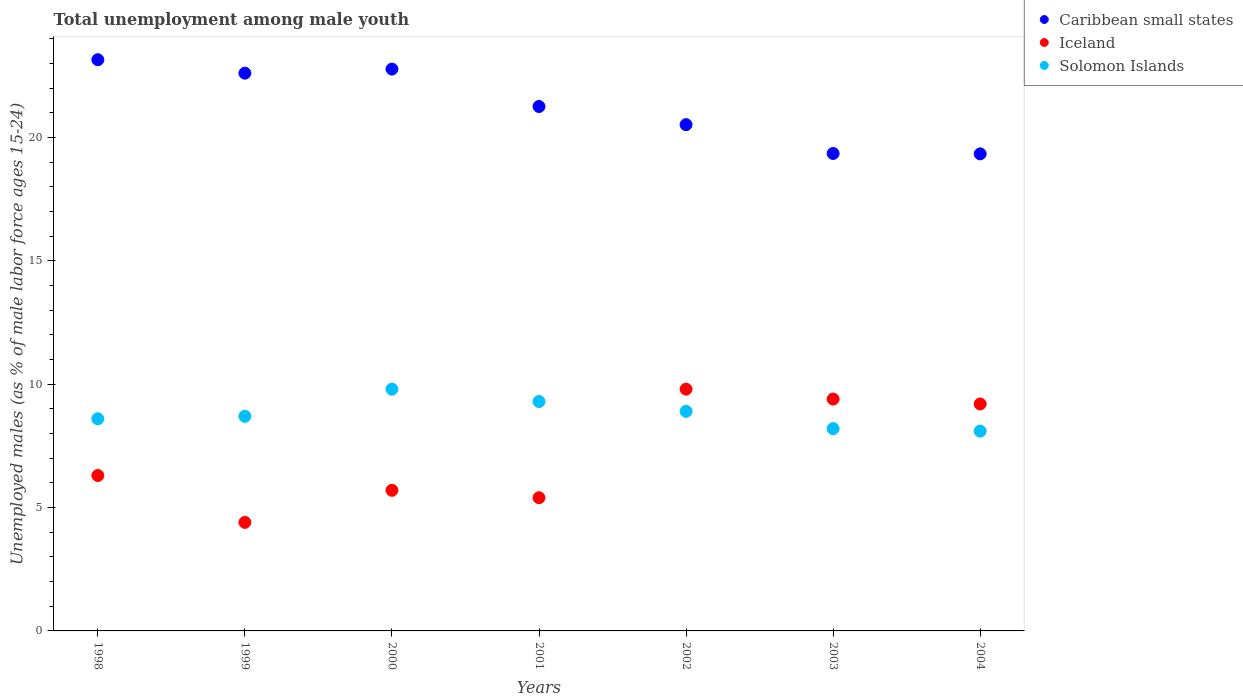Is the number of dotlines equal to the number of legend labels?
Make the answer very short. Yes. What is the percentage of unemployed males in in Caribbean small states in 1999?
Your response must be concise. 22.61. Across all years, what is the maximum percentage of unemployed males in in Solomon Islands?
Your answer should be compact. 9.8. Across all years, what is the minimum percentage of unemployed males in in Caribbean small states?
Provide a succinct answer. 19.34. What is the total percentage of unemployed males in in Iceland in the graph?
Your answer should be very brief. 50.2. What is the difference between the percentage of unemployed males in in Caribbean small states in 1998 and that in 2002?
Your answer should be compact. 2.63. What is the difference between the percentage of unemployed males in in Solomon Islands in 2004 and the percentage of unemployed males in in Iceland in 1999?
Offer a terse response. 3.7. What is the average percentage of unemployed males in in Iceland per year?
Offer a terse response. 7.17. In the year 2002, what is the difference between the percentage of unemployed males in in Caribbean small states and percentage of unemployed males in in Iceland?
Keep it short and to the point. 10.72. What is the ratio of the percentage of unemployed males in in Caribbean small states in 1998 to that in 2004?
Offer a terse response. 1.2. Is the percentage of unemployed males in in Solomon Islands in 1998 less than that in 2000?
Give a very brief answer. Yes. What is the difference between the highest and the second highest percentage of unemployed males in in Solomon Islands?
Your answer should be very brief. 0.5. What is the difference between the highest and the lowest percentage of unemployed males in in Caribbean small states?
Keep it short and to the point. 3.82. Is it the case that in every year, the sum of the percentage of unemployed males in in Solomon Islands and percentage of unemployed males in in Iceland  is greater than the percentage of unemployed males in in Caribbean small states?
Your response must be concise. No. Does the graph contain any zero values?
Keep it short and to the point. No. How many legend labels are there?
Keep it short and to the point. 3. What is the title of the graph?
Provide a succinct answer. Total unemployment among male youth. Does "Estonia" appear as one of the legend labels in the graph?
Offer a terse response. No. What is the label or title of the X-axis?
Give a very brief answer. Years. What is the label or title of the Y-axis?
Your answer should be very brief. Unemployed males (as % of male labor force ages 15-24). What is the Unemployed males (as % of male labor force ages 15-24) of Caribbean small states in 1998?
Make the answer very short. 23.16. What is the Unemployed males (as % of male labor force ages 15-24) in Iceland in 1998?
Keep it short and to the point. 6.3. What is the Unemployed males (as % of male labor force ages 15-24) of Solomon Islands in 1998?
Give a very brief answer. 8.6. What is the Unemployed males (as % of male labor force ages 15-24) of Caribbean small states in 1999?
Provide a succinct answer. 22.61. What is the Unemployed males (as % of male labor force ages 15-24) in Iceland in 1999?
Provide a short and direct response. 4.4. What is the Unemployed males (as % of male labor force ages 15-24) of Solomon Islands in 1999?
Make the answer very short. 8.7. What is the Unemployed males (as % of male labor force ages 15-24) of Caribbean small states in 2000?
Your answer should be compact. 22.78. What is the Unemployed males (as % of male labor force ages 15-24) in Iceland in 2000?
Make the answer very short. 5.7. What is the Unemployed males (as % of male labor force ages 15-24) in Solomon Islands in 2000?
Keep it short and to the point. 9.8. What is the Unemployed males (as % of male labor force ages 15-24) in Caribbean small states in 2001?
Give a very brief answer. 21.26. What is the Unemployed males (as % of male labor force ages 15-24) of Iceland in 2001?
Your answer should be compact. 5.4. What is the Unemployed males (as % of male labor force ages 15-24) of Solomon Islands in 2001?
Provide a short and direct response. 9.3. What is the Unemployed males (as % of male labor force ages 15-24) in Caribbean small states in 2002?
Offer a very short reply. 20.52. What is the Unemployed males (as % of male labor force ages 15-24) of Iceland in 2002?
Your answer should be compact. 9.8. What is the Unemployed males (as % of male labor force ages 15-24) of Solomon Islands in 2002?
Make the answer very short. 8.9. What is the Unemployed males (as % of male labor force ages 15-24) of Caribbean small states in 2003?
Your response must be concise. 19.35. What is the Unemployed males (as % of male labor force ages 15-24) in Iceland in 2003?
Your response must be concise. 9.4. What is the Unemployed males (as % of male labor force ages 15-24) of Solomon Islands in 2003?
Give a very brief answer. 8.2. What is the Unemployed males (as % of male labor force ages 15-24) of Caribbean small states in 2004?
Offer a very short reply. 19.34. What is the Unemployed males (as % of male labor force ages 15-24) of Iceland in 2004?
Your response must be concise. 9.2. What is the Unemployed males (as % of male labor force ages 15-24) of Solomon Islands in 2004?
Provide a succinct answer. 8.1. Across all years, what is the maximum Unemployed males (as % of male labor force ages 15-24) in Caribbean small states?
Offer a very short reply. 23.16. Across all years, what is the maximum Unemployed males (as % of male labor force ages 15-24) of Iceland?
Give a very brief answer. 9.8. Across all years, what is the maximum Unemployed males (as % of male labor force ages 15-24) of Solomon Islands?
Offer a terse response. 9.8. Across all years, what is the minimum Unemployed males (as % of male labor force ages 15-24) in Caribbean small states?
Your response must be concise. 19.34. Across all years, what is the minimum Unemployed males (as % of male labor force ages 15-24) of Iceland?
Provide a short and direct response. 4.4. Across all years, what is the minimum Unemployed males (as % of male labor force ages 15-24) of Solomon Islands?
Your answer should be compact. 8.1. What is the total Unemployed males (as % of male labor force ages 15-24) of Caribbean small states in the graph?
Offer a terse response. 149.02. What is the total Unemployed males (as % of male labor force ages 15-24) of Iceland in the graph?
Ensure brevity in your answer.  50.2. What is the total Unemployed males (as % of male labor force ages 15-24) in Solomon Islands in the graph?
Ensure brevity in your answer.  61.6. What is the difference between the Unemployed males (as % of male labor force ages 15-24) of Caribbean small states in 1998 and that in 1999?
Ensure brevity in your answer.  0.55. What is the difference between the Unemployed males (as % of male labor force ages 15-24) in Solomon Islands in 1998 and that in 1999?
Give a very brief answer. -0.1. What is the difference between the Unemployed males (as % of male labor force ages 15-24) in Caribbean small states in 1998 and that in 2000?
Ensure brevity in your answer.  0.38. What is the difference between the Unemployed males (as % of male labor force ages 15-24) in Iceland in 1998 and that in 2000?
Your answer should be very brief. 0.6. What is the difference between the Unemployed males (as % of male labor force ages 15-24) of Solomon Islands in 1998 and that in 2000?
Keep it short and to the point. -1.2. What is the difference between the Unemployed males (as % of male labor force ages 15-24) in Caribbean small states in 1998 and that in 2001?
Your answer should be compact. 1.9. What is the difference between the Unemployed males (as % of male labor force ages 15-24) in Iceland in 1998 and that in 2001?
Offer a terse response. 0.9. What is the difference between the Unemployed males (as % of male labor force ages 15-24) in Caribbean small states in 1998 and that in 2002?
Offer a very short reply. 2.63. What is the difference between the Unemployed males (as % of male labor force ages 15-24) of Caribbean small states in 1998 and that in 2003?
Your response must be concise. 3.8. What is the difference between the Unemployed males (as % of male labor force ages 15-24) of Iceland in 1998 and that in 2003?
Make the answer very short. -3.1. What is the difference between the Unemployed males (as % of male labor force ages 15-24) in Solomon Islands in 1998 and that in 2003?
Give a very brief answer. 0.4. What is the difference between the Unemployed males (as % of male labor force ages 15-24) of Caribbean small states in 1998 and that in 2004?
Offer a very short reply. 3.82. What is the difference between the Unemployed males (as % of male labor force ages 15-24) in Solomon Islands in 1998 and that in 2004?
Provide a succinct answer. 0.5. What is the difference between the Unemployed males (as % of male labor force ages 15-24) in Caribbean small states in 1999 and that in 2000?
Ensure brevity in your answer.  -0.16. What is the difference between the Unemployed males (as % of male labor force ages 15-24) of Solomon Islands in 1999 and that in 2000?
Make the answer very short. -1.1. What is the difference between the Unemployed males (as % of male labor force ages 15-24) of Caribbean small states in 1999 and that in 2001?
Ensure brevity in your answer.  1.35. What is the difference between the Unemployed males (as % of male labor force ages 15-24) in Iceland in 1999 and that in 2001?
Ensure brevity in your answer.  -1. What is the difference between the Unemployed males (as % of male labor force ages 15-24) in Caribbean small states in 1999 and that in 2002?
Your response must be concise. 2.09. What is the difference between the Unemployed males (as % of male labor force ages 15-24) of Iceland in 1999 and that in 2002?
Keep it short and to the point. -5.4. What is the difference between the Unemployed males (as % of male labor force ages 15-24) in Caribbean small states in 1999 and that in 2003?
Your answer should be compact. 3.26. What is the difference between the Unemployed males (as % of male labor force ages 15-24) in Iceland in 1999 and that in 2003?
Offer a terse response. -5. What is the difference between the Unemployed males (as % of male labor force ages 15-24) in Caribbean small states in 1999 and that in 2004?
Your answer should be compact. 3.27. What is the difference between the Unemployed males (as % of male labor force ages 15-24) of Iceland in 1999 and that in 2004?
Ensure brevity in your answer.  -4.8. What is the difference between the Unemployed males (as % of male labor force ages 15-24) in Caribbean small states in 2000 and that in 2001?
Offer a terse response. 1.52. What is the difference between the Unemployed males (as % of male labor force ages 15-24) of Iceland in 2000 and that in 2001?
Keep it short and to the point. 0.3. What is the difference between the Unemployed males (as % of male labor force ages 15-24) of Caribbean small states in 2000 and that in 2002?
Make the answer very short. 2.25. What is the difference between the Unemployed males (as % of male labor force ages 15-24) in Solomon Islands in 2000 and that in 2002?
Provide a short and direct response. 0.9. What is the difference between the Unemployed males (as % of male labor force ages 15-24) in Caribbean small states in 2000 and that in 2003?
Give a very brief answer. 3.42. What is the difference between the Unemployed males (as % of male labor force ages 15-24) in Solomon Islands in 2000 and that in 2003?
Provide a short and direct response. 1.6. What is the difference between the Unemployed males (as % of male labor force ages 15-24) of Caribbean small states in 2000 and that in 2004?
Your response must be concise. 3.44. What is the difference between the Unemployed males (as % of male labor force ages 15-24) in Solomon Islands in 2000 and that in 2004?
Keep it short and to the point. 1.7. What is the difference between the Unemployed males (as % of male labor force ages 15-24) of Caribbean small states in 2001 and that in 2002?
Give a very brief answer. 0.74. What is the difference between the Unemployed males (as % of male labor force ages 15-24) in Caribbean small states in 2001 and that in 2003?
Give a very brief answer. 1.91. What is the difference between the Unemployed males (as % of male labor force ages 15-24) in Iceland in 2001 and that in 2003?
Your response must be concise. -4. What is the difference between the Unemployed males (as % of male labor force ages 15-24) in Caribbean small states in 2001 and that in 2004?
Your response must be concise. 1.92. What is the difference between the Unemployed males (as % of male labor force ages 15-24) of Solomon Islands in 2001 and that in 2004?
Your answer should be very brief. 1.2. What is the difference between the Unemployed males (as % of male labor force ages 15-24) of Caribbean small states in 2002 and that in 2003?
Your response must be concise. 1.17. What is the difference between the Unemployed males (as % of male labor force ages 15-24) in Caribbean small states in 2002 and that in 2004?
Offer a very short reply. 1.18. What is the difference between the Unemployed males (as % of male labor force ages 15-24) of Iceland in 2002 and that in 2004?
Keep it short and to the point. 0.6. What is the difference between the Unemployed males (as % of male labor force ages 15-24) of Solomon Islands in 2002 and that in 2004?
Provide a short and direct response. 0.8. What is the difference between the Unemployed males (as % of male labor force ages 15-24) of Caribbean small states in 2003 and that in 2004?
Offer a terse response. 0.01. What is the difference between the Unemployed males (as % of male labor force ages 15-24) of Iceland in 2003 and that in 2004?
Your response must be concise. 0.2. What is the difference between the Unemployed males (as % of male labor force ages 15-24) in Caribbean small states in 1998 and the Unemployed males (as % of male labor force ages 15-24) in Iceland in 1999?
Your answer should be very brief. 18.76. What is the difference between the Unemployed males (as % of male labor force ages 15-24) of Caribbean small states in 1998 and the Unemployed males (as % of male labor force ages 15-24) of Solomon Islands in 1999?
Your answer should be very brief. 14.46. What is the difference between the Unemployed males (as % of male labor force ages 15-24) of Iceland in 1998 and the Unemployed males (as % of male labor force ages 15-24) of Solomon Islands in 1999?
Offer a very short reply. -2.4. What is the difference between the Unemployed males (as % of male labor force ages 15-24) in Caribbean small states in 1998 and the Unemployed males (as % of male labor force ages 15-24) in Iceland in 2000?
Give a very brief answer. 17.46. What is the difference between the Unemployed males (as % of male labor force ages 15-24) in Caribbean small states in 1998 and the Unemployed males (as % of male labor force ages 15-24) in Solomon Islands in 2000?
Make the answer very short. 13.36. What is the difference between the Unemployed males (as % of male labor force ages 15-24) in Iceland in 1998 and the Unemployed males (as % of male labor force ages 15-24) in Solomon Islands in 2000?
Offer a very short reply. -3.5. What is the difference between the Unemployed males (as % of male labor force ages 15-24) of Caribbean small states in 1998 and the Unemployed males (as % of male labor force ages 15-24) of Iceland in 2001?
Keep it short and to the point. 17.76. What is the difference between the Unemployed males (as % of male labor force ages 15-24) in Caribbean small states in 1998 and the Unemployed males (as % of male labor force ages 15-24) in Solomon Islands in 2001?
Your answer should be compact. 13.86. What is the difference between the Unemployed males (as % of male labor force ages 15-24) of Caribbean small states in 1998 and the Unemployed males (as % of male labor force ages 15-24) of Iceland in 2002?
Provide a succinct answer. 13.36. What is the difference between the Unemployed males (as % of male labor force ages 15-24) of Caribbean small states in 1998 and the Unemployed males (as % of male labor force ages 15-24) of Solomon Islands in 2002?
Give a very brief answer. 14.26. What is the difference between the Unemployed males (as % of male labor force ages 15-24) of Iceland in 1998 and the Unemployed males (as % of male labor force ages 15-24) of Solomon Islands in 2002?
Offer a terse response. -2.6. What is the difference between the Unemployed males (as % of male labor force ages 15-24) of Caribbean small states in 1998 and the Unemployed males (as % of male labor force ages 15-24) of Iceland in 2003?
Provide a short and direct response. 13.76. What is the difference between the Unemployed males (as % of male labor force ages 15-24) of Caribbean small states in 1998 and the Unemployed males (as % of male labor force ages 15-24) of Solomon Islands in 2003?
Provide a short and direct response. 14.96. What is the difference between the Unemployed males (as % of male labor force ages 15-24) in Iceland in 1998 and the Unemployed males (as % of male labor force ages 15-24) in Solomon Islands in 2003?
Keep it short and to the point. -1.9. What is the difference between the Unemployed males (as % of male labor force ages 15-24) in Caribbean small states in 1998 and the Unemployed males (as % of male labor force ages 15-24) in Iceland in 2004?
Ensure brevity in your answer.  13.96. What is the difference between the Unemployed males (as % of male labor force ages 15-24) in Caribbean small states in 1998 and the Unemployed males (as % of male labor force ages 15-24) in Solomon Islands in 2004?
Offer a very short reply. 15.06. What is the difference between the Unemployed males (as % of male labor force ages 15-24) in Iceland in 1998 and the Unemployed males (as % of male labor force ages 15-24) in Solomon Islands in 2004?
Ensure brevity in your answer.  -1.8. What is the difference between the Unemployed males (as % of male labor force ages 15-24) of Caribbean small states in 1999 and the Unemployed males (as % of male labor force ages 15-24) of Iceland in 2000?
Provide a succinct answer. 16.91. What is the difference between the Unemployed males (as % of male labor force ages 15-24) in Caribbean small states in 1999 and the Unemployed males (as % of male labor force ages 15-24) in Solomon Islands in 2000?
Offer a very short reply. 12.81. What is the difference between the Unemployed males (as % of male labor force ages 15-24) of Caribbean small states in 1999 and the Unemployed males (as % of male labor force ages 15-24) of Iceland in 2001?
Your response must be concise. 17.21. What is the difference between the Unemployed males (as % of male labor force ages 15-24) in Caribbean small states in 1999 and the Unemployed males (as % of male labor force ages 15-24) in Solomon Islands in 2001?
Make the answer very short. 13.31. What is the difference between the Unemployed males (as % of male labor force ages 15-24) in Caribbean small states in 1999 and the Unemployed males (as % of male labor force ages 15-24) in Iceland in 2002?
Provide a short and direct response. 12.81. What is the difference between the Unemployed males (as % of male labor force ages 15-24) in Caribbean small states in 1999 and the Unemployed males (as % of male labor force ages 15-24) in Solomon Islands in 2002?
Offer a terse response. 13.71. What is the difference between the Unemployed males (as % of male labor force ages 15-24) in Caribbean small states in 1999 and the Unemployed males (as % of male labor force ages 15-24) in Iceland in 2003?
Offer a terse response. 13.21. What is the difference between the Unemployed males (as % of male labor force ages 15-24) in Caribbean small states in 1999 and the Unemployed males (as % of male labor force ages 15-24) in Solomon Islands in 2003?
Your response must be concise. 14.41. What is the difference between the Unemployed males (as % of male labor force ages 15-24) of Caribbean small states in 1999 and the Unemployed males (as % of male labor force ages 15-24) of Iceland in 2004?
Offer a very short reply. 13.41. What is the difference between the Unemployed males (as % of male labor force ages 15-24) in Caribbean small states in 1999 and the Unemployed males (as % of male labor force ages 15-24) in Solomon Islands in 2004?
Ensure brevity in your answer.  14.51. What is the difference between the Unemployed males (as % of male labor force ages 15-24) in Caribbean small states in 2000 and the Unemployed males (as % of male labor force ages 15-24) in Iceland in 2001?
Your answer should be very brief. 17.38. What is the difference between the Unemployed males (as % of male labor force ages 15-24) in Caribbean small states in 2000 and the Unemployed males (as % of male labor force ages 15-24) in Solomon Islands in 2001?
Offer a very short reply. 13.48. What is the difference between the Unemployed males (as % of male labor force ages 15-24) in Iceland in 2000 and the Unemployed males (as % of male labor force ages 15-24) in Solomon Islands in 2001?
Keep it short and to the point. -3.6. What is the difference between the Unemployed males (as % of male labor force ages 15-24) in Caribbean small states in 2000 and the Unemployed males (as % of male labor force ages 15-24) in Iceland in 2002?
Offer a very short reply. 12.98. What is the difference between the Unemployed males (as % of male labor force ages 15-24) of Caribbean small states in 2000 and the Unemployed males (as % of male labor force ages 15-24) of Solomon Islands in 2002?
Provide a short and direct response. 13.88. What is the difference between the Unemployed males (as % of male labor force ages 15-24) in Iceland in 2000 and the Unemployed males (as % of male labor force ages 15-24) in Solomon Islands in 2002?
Provide a short and direct response. -3.2. What is the difference between the Unemployed males (as % of male labor force ages 15-24) of Caribbean small states in 2000 and the Unemployed males (as % of male labor force ages 15-24) of Iceland in 2003?
Ensure brevity in your answer.  13.38. What is the difference between the Unemployed males (as % of male labor force ages 15-24) in Caribbean small states in 2000 and the Unemployed males (as % of male labor force ages 15-24) in Solomon Islands in 2003?
Offer a very short reply. 14.58. What is the difference between the Unemployed males (as % of male labor force ages 15-24) in Caribbean small states in 2000 and the Unemployed males (as % of male labor force ages 15-24) in Iceland in 2004?
Your answer should be compact. 13.58. What is the difference between the Unemployed males (as % of male labor force ages 15-24) in Caribbean small states in 2000 and the Unemployed males (as % of male labor force ages 15-24) in Solomon Islands in 2004?
Provide a short and direct response. 14.68. What is the difference between the Unemployed males (as % of male labor force ages 15-24) of Iceland in 2000 and the Unemployed males (as % of male labor force ages 15-24) of Solomon Islands in 2004?
Provide a succinct answer. -2.4. What is the difference between the Unemployed males (as % of male labor force ages 15-24) of Caribbean small states in 2001 and the Unemployed males (as % of male labor force ages 15-24) of Iceland in 2002?
Give a very brief answer. 11.46. What is the difference between the Unemployed males (as % of male labor force ages 15-24) in Caribbean small states in 2001 and the Unemployed males (as % of male labor force ages 15-24) in Solomon Islands in 2002?
Provide a short and direct response. 12.36. What is the difference between the Unemployed males (as % of male labor force ages 15-24) of Caribbean small states in 2001 and the Unemployed males (as % of male labor force ages 15-24) of Iceland in 2003?
Provide a short and direct response. 11.86. What is the difference between the Unemployed males (as % of male labor force ages 15-24) of Caribbean small states in 2001 and the Unemployed males (as % of male labor force ages 15-24) of Solomon Islands in 2003?
Offer a very short reply. 13.06. What is the difference between the Unemployed males (as % of male labor force ages 15-24) in Caribbean small states in 2001 and the Unemployed males (as % of male labor force ages 15-24) in Iceland in 2004?
Offer a very short reply. 12.06. What is the difference between the Unemployed males (as % of male labor force ages 15-24) of Caribbean small states in 2001 and the Unemployed males (as % of male labor force ages 15-24) of Solomon Islands in 2004?
Your answer should be very brief. 13.16. What is the difference between the Unemployed males (as % of male labor force ages 15-24) in Caribbean small states in 2002 and the Unemployed males (as % of male labor force ages 15-24) in Iceland in 2003?
Offer a very short reply. 11.12. What is the difference between the Unemployed males (as % of male labor force ages 15-24) of Caribbean small states in 2002 and the Unemployed males (as % of male labor force ages 15-24) of Solomon Islands in 2003?
Provide a succinct answer. 12.32. What is the difference between the Unemployed males (as % of male labor force ages 15-24) of Caribbean small states in 2002 and the Unemployed males (as % of male labor force ages 15-24) of Iceland in 2004?
Your answer should be very brief. 11.32. What is the difference between the Unemployed males (as % of male labor force ages 15-24) in Caribbean small states in 2002 and the Unemployed males (as % of male labor force ages 15-24) in Solomon Islands in 2004?
Keep it short and to the point. 12.42. What is the difference between the Unemployed males (as % of male labor force ages 15-24) of Caribbean small states in 2003 and the Unemployed males (as % of male labor force ages 15-24) of Iceland in 2004?
Your response must be concise. 10.15. What is the difference between the Unemployed males (as % of male labor force ages 15-24) of Caribbean small states in 2003 and the Unemployed males (as % of male labor force ages 15-24) of Solomon Islands in 2004?
Your response must be concise. 11.25. What is the difference between the Unemployed males (as % of male labor force ages 15-24) in Iceland in 2003 and the Unemployed males (as % of male labor force ages 15-24) in Solomon Islands in 2004?
Offer a very short reply. 1.3. What is the average Unemployed males (as % of male labor force ages 15-24) of Caribbean small states per year?
Offer a very short reply. 21.29. What is the average Unemployed males (as % of male labor force ages 15-24) in Iceland per year?
Give a very brief answer. 7.17. What is the average Unemployed males (as % of male labor force ages 15-24) of Solomon Islands per year?
Give a very brief answer. 8.8. In the year 1998, what is the difference between the Unemployed males (as % of male labor force ages 15-24) in Caribbean small states and Unemployed males (as % of male labor force ages 15-24) in Iceland?
Your response must be concise. 16.86. In the year 1998, what is the difference between the Unemployed males (as % of male labor force ages 15-24) of Caribbean small states and Unemployed males (as % of male labor force ages 15-24) of Solomon Islands?
Your answer should be very brief. 14.56. In the year 1999, what is the difference between the Unemployed males (as % of male labor force ages 15-24) of Caribbean small states and Unemployed males (as % of male labor force ages 15-24) of Iceland?
Offer a very short reply. 18.21. In the year 1999, what is the difference between the Unemployed males (as % of male labor force ages 15-24) in Caribbean small states and Unemployed males (as % of male labor force ages 15-24) in Solomon Islands?
Offer a terse response. 13.91. In the year 2000, what is the difference between the Unemployed males (as % of male labor force ages 15-24) in Caribbean small states and Unemployed males (as % of male labor force ages 15-24) in Iceland?
Your response must be concise. 17.08. In the year 2000, what is the difference between the Unemployed males (as % of male labor force ages 15-24) of Caribbean small states and Unemployed males (as % of male labor force ages 15-24) of Solomon Islands?
Make the answer very short. 12.98. In the year 2001, what is the difference between the Unemployed males (as % of male labor force ages 15-24) of Caribbean small states and Unemployed males (as % of male labor force ages 15-24) of Iceland?
Your answer should be very brief. 15.86. In the year 2001, what is the difference between the Unemployed males (as % of male labor force ages 15-24) in Caribbean small states and Unemployed males (as % of male labor force ages 15-24) in Solomon Islands?
Offer a terse response. 11.96. In the year 2001, what is the difference between the Unemployed males (as % of male labor force ages 15-24) of Iceland and Unemployed males (as % of male labor force ages 15-24) of Solomon Islands?
Offer a terse response. -3.9. In the year 2002, what is the difference between the Unemployed males (as % of male labor force ages 15-24) of Caribbean small states and Unemployed males (as % of male labor force ages 15-24) of Iceland?
Offer a terse response. 10.72. In the year 2002, what is the difference between the Unemployed males (as % of male labor force ages 15-24) in Caribbean small states and Unemployed males (as % of male labor force ages 15-24) in Solomon Islands?
Give a very brief answer. 11.62. In the year 2002, what is the difference between the Unemployed males (as % of male labor force ages 15-24) in Iceland and Unemployed males (as % of male labor force ages 15-24) in Solomon Islands?
Offer a terse response. 0.9. In the year 2003, what is the difference between the Unemployed males (as % of male labor force ages 15-24) of Caribbean small states and Unemployed males (as % of male labor force ages 15-24) of Iceland?
Ensure brevity in your answer.  9.95. In the year 2003, what is the difference between the Unemployed males (as % of male labor force ages 15-24) of Caribbean small states and Unemployed males (as % of male labor force ages 15-24) of Solomon Islands?
Give a very brief answer. 11.15. In the year 2004, what is the difference between the Unemployed males (as % of male labor force ages 15-24) of Caribbean small states and Unemployed males (as % of male labor force ages 15-24) of Iceland?
Your answer should be very brief. 10.14. In the year 2004, what is the difference between the Unemployed males (as % of male labor force ages 15-24) in Caribbean small states and Unemployed males (as % of male labor force ages 15-24) in Solomon Islands?
Provide a short and direct response. 11.24. In the year 2004, what is the difference between the Unemployed males (as % of male labor force ages 15-24) of Iceland and Unemployed males (as % of male labor force ages 15-24) of Solomon Islands?
Offer a terse response. 1.1. What is the ratio of the Unemployed males (as % of male labor force ages 15-24) in Caribbean small states in 1998 to that in 1999?
Make the answer very short. 1.02. What is the ratio of the Unemployed males (as % of male labor force ages 15-24) in Iceland in 1998 to that in 1999?
Ensure brevity in your answer.  1.43. What is the ratio of the Unemployed males (as % of male labor force ages 15-24) of Solomon Islands in 1998 to that in 1999?
Your answer should be very brief. 0.99. What is the ratio of the Unemployed males (as % of male labor force ages 15-24) in Caribbean small states in 1998 to that in 2000?
Offer a terse response. 1.02. What is the ratio of the Unemployed males (as % of male labor force ages 15-24) in Iceland in 1998 to that in 2000?
Your answer should be very brief. 1.11. What is the ratio of the Unemployed males (as % of male labor force ages 15-24) of Solomon Islands in 1998 to that in 2000?
Your answer should be compact. 0.88. What is the ratio of the Unemployed males (as % of male labor force ages 15-24) in Caribbean small states in 1998 to that in 2001?
Ensure brevity in your answer.  1.09. What is the ratio of the Unemployed males (as % of male labor force ages 15-24) of Iceland in 1998 to that in 2001?
Ensure brevity in your answer.  1.17. What is the ratio of the Unemployed males (as % of male labor force ages 15-24) of Solomon Islands in 1998 to that in 2001?
Keep it short and to the point. 0.92. What is the ratio of the Unemployed males (as % of male labor force ages 15-24) of Caribbean small states in 1998 to that in 2002?
Ensure brevity in your answer.  1.13. What is the ratio of the Unemployed males (as % of male labor force ages 15-24) in Iceland in 1998 to that in 2002?
Provide a succinct answer. 0.64. What is the ratio of the Unemployed males (as % of male labor force ages 15-24) of Solomon Islands in 1998 to that in 2002?
Your answer should be compact. 0.97. What is the ratio of the Unemployed males (as % of male labor force ages 15-24) of Caribbean small states in 1998 to that in 2003?
Make the answer very short. 1.2. What is the ratio of the Unemployed males (as % of male labor force ages 15-24) in Iceland in 1998 to that in 2003?
Your answer should be compact. 0.67. What is the ratio of the Unemployed males (as % of male labor force ages 15-24) of Solomon Islands in 1998 to that in 2003?
Keep it short and to the point. 1.05. What is the ratio of the Unemployed males (as % of male labor force ages 15-24) in Caribbean small states in 1998 to that in 2004?
Provide a short and direct response. 1.2. What is the ratio of the Unemployed males (as % of male labor force ages 15-24) of Iceland in 1998 to that in 2004?
Your answer should be compact. 0.68. What is the ratio of the Unemployed males (as % of male labor force ages 15-24) in Solomon Islands in 1998 to that in 2004?
Your answer should be very brief. 1.06. What is the ratio of the Unemployed males (as % of male labor force ages 15-24) of Caribbean small states in 1999 to that in 2000?
Provide a short and direct response. 0.99. What is the ratio of the Unemployed males (as % of male labor force ages 15-24) of Iceland in 1999 to that in 2000?
Offer a very short reply. 0.77. What is the ratio of the Unemployed males (as % of male labor force ages 15-24) in Solomon Islands in 1999 to that in 2000?
Ensure brevity in your answer.  0.89. What is the ratio of the Unemployed males (as % of male labor force ages 15-24) of Caribbean small states in 1999 to that in 2001?
Provide a short and direct response. 1.06. What is the ratio of the Unemployed males (as % of male labor force ages 15-24) in Iceland in 1999 to that in 2001?
Provide a short and direct response. 0.81. What is the ratio of the Unemployed males (as % of male labor force ages 15-24) in Solomon Islands in 1999 to that in 2001?
Your answer should be very brief. 0.94. What is the ratio of the Unemployed males (as % of male labor force ages 15-24) in Caribbean small states in 1999 to that in 2002?
Your response must be concise. 1.1. What is the ratio of the Unemployed males (as % of male labor force ages 15-24) of Iceland in 1999 to that in 2002?
Keep it short and to the point. 0.45. What is the ratio of the Unemployed males (as % of male labor force ages 15-24) of Solomon Islands in 1999 to that in 2002?
Offer a very short reply. 0.98. What is the ratio of the Unemployed males (as % of male labor force ages 15-24) of Caribbean small states in 1999 to that in 2003?
Offer a very short reply. 1.17. What is the ratio of the Unemployed males (as % of male labor force ages 15-24) of Iceland in 1999 to that in 2003?
Provide a succinct answer. 0.47. What is the ratio of the Unemployed males (as % of male labor force ages 15-24) of Solomon Islands in 1999 to that in 2003?
Your answer should be compact. 1.06. What is the ratio of the Unemployed males (as % of male labor force ages 15-24) in Caribbean small states in 1999 to that in 2004?
Offer a terse response. 1.17. What is the ratio of the Unemployed males (as % of male labor force ages 15-24) in Iceland in 1999 to that in 2004?
Keep it short and to the point. 0.48. What is the ratio of the Unemployed males (as % of male labor force ages 15-24) in Solomon Islands in 1999 to that in 2004?
Provide a succinct answer. 1.07. What is the ratio of the Unemployed males (as % of male labor force ages 15-24) in Caribbean small states in 2000 to that in 2001?
Make the answer very short. 1.07. What is the ratio of the Unemployed males (as % of male labor force ages 15-24) of Iceland in 2000 to that in 2001?
Ensure brevity in your answer.  1.06. What is the ratio of the Unemployed males (as % of male labor force ages 15-24) of Solomon Islands in 2000 to that in 2001?
Ensure brevity in your answer.  1.05. What is the ratio of the Unemployed males (as % of male labor force ages 15-24) in Caribbean small states in 2000 to that in 2002?
Offer a very short reply. 1.11. What is the ratio of the Unemployed males (as % of male labor force ages 15-24) of Iceland in 2000 to that in 2002?
Make the answer very short. 0.58. What is the ratio of the Unemployed males (as % of male labor force ages 15-24) of Solomon Islands in 2000 to that in 2002?
Your answer should be compact. 1.1. What is the ratio of the Unemployed males (as % of male labor force ages 15-24) of Caribbean small states in 2000 to that in 2003?
Provide a short and direct response. 1.18. What is the ratio of the Unemployed males (as % of male labor force ages 15-24) in Iceland in 2000 to that in 2003?
Make the answer very short. 0.61. What is the ratio of the Unemployed males (as % of male labor force ages 15-24) in Solomon Islands in 2000 to that in 2003?
Offer a very short reply. 1.2. What is the ratio of the Unemployed males (as % of male labor force ages 15-24) of Caribbean small states in 2000 to that in 2004?
Give a very brief answer. 1.18. What is the ratio of the Unemployed males (as % of male labor force ages 15-24) in Iceland in 2000 to that in 2004?
Ensure brevity in your answer.  0.62. What is the ratio of the Unemployed males (as % of male labor force ages 15-24) of Solomon Islands in 2000 to that in 2004?
Provide a succinct answer. 1.21. What is the ratio of the Unemployed males (as % of male labor force ages 15-24) of Caribbean small states in 2001 to that in 2002?
Your response must be concise. 1.04. What is the ratio of the Unemployed males (as % of male labor force ages 15-24) of Iceland in 2001 to that in 2002?
Make the answer very short. 0.55. What is the ratio of the Unemployed males (as % of male labor force ages 15-24) of Solomon Islands in 2001 to that in 2002?
Offer a terse response. 1.04. What is the ratio of the Unemployed males (as % of male labor force ages 15-24) of Caribbean small states in 2001 to that in 2003?
Give a very brief answer. 1.1. What is the ratio of the Unemployed males (as % of male labor force ages 15-24) of Iceland in 2001 to that in 2003?
Offer a very short reply. 0.57. What is the ratio of the Unemployed males (as % of male labor force ages 15-24) of Solomon Islands in 2001 to that in 2003?
Your response must be concise. 1.13. What is the ratio of the Unemployed males (as % of male labor force ages 15-24) of Caribbean small states in 2001 to that in 2004?
Keep it short and to the point. 1.1. What is the ratio of the Unemployed males (as % of male labor force ages 15-24) of Iceland in 2001 to that in 2004?
Keep it short and to the point. 0.59. What is the ratio of the Unemployed males (as % of male labor force ages 15-24) of Solomon Islands in 2001 to that in 2004?
Ensure brevity in your answer.  1.15. What is the ratio of the Unemployed males (as % of male labor force ages 15-24) of Caribbean small states in 2002 to that in 2003?
Make the answer very short. 1.06. What is the ratio of the Unemployed males (as % of male labor force ages 15-24) of Iceland in 2002 to that in 2003?
Make the answer very short. 1.04. What is the ratio of the Unemployed males (as % of male labor force ages 15-24) of Solomon Islands in 2002 to that in 2003?
Keep it short and to the point. 1.09. What is the ratio of the Unemployed males (as % of male labor force ages 15-24) of Caribbean small states in 2002 to that in 2004?
Your answer should be compact. 1.06. What is the ratio of the Unemployed males (as % of male labor force ages 15-24) in Iceland in 2002 to that in 2004?
Make the answer very short. 1.07. What is the ratio of the Unemployed males (as % of male labor force ages 15-24) of Solomon Islands in 2002 to that in 2004?
Give a very brief answer. 1.1. What is the ratio of the Unemployed males (as % of male labor force ages 15-24) in Caribbean small states in 2003 to that in 2004?
Your answer should be very brief. 1. What is the ratio of the Unemployed males (as % of male labor force ages 15-24) of Iceland in 2003 to that in 2004?
Give a very brief answer. 1.02. What is the ratio of the Unemployed males (as % of male labor force ages 15-24) of Solomon Islands in 2003 to that in 2004?
Your answer should be very brief. 1.01. What is the difference between the highest and the second highest Unemployed males (as % of male labor force ages 15-24) of Caribbean small states?
Offer a very short reply. 0.38. What is the difference between the highest and the second highest Unemployed males (as % of male labor force ages 15-24) in Iceland?
Make the answer very short. 0.4. What is the difference between the highest and the lowest Unemployed males (as % of male labor force ages 15-24) of Caribbean small states?
Ensure brevity in your answer.  3.82. 